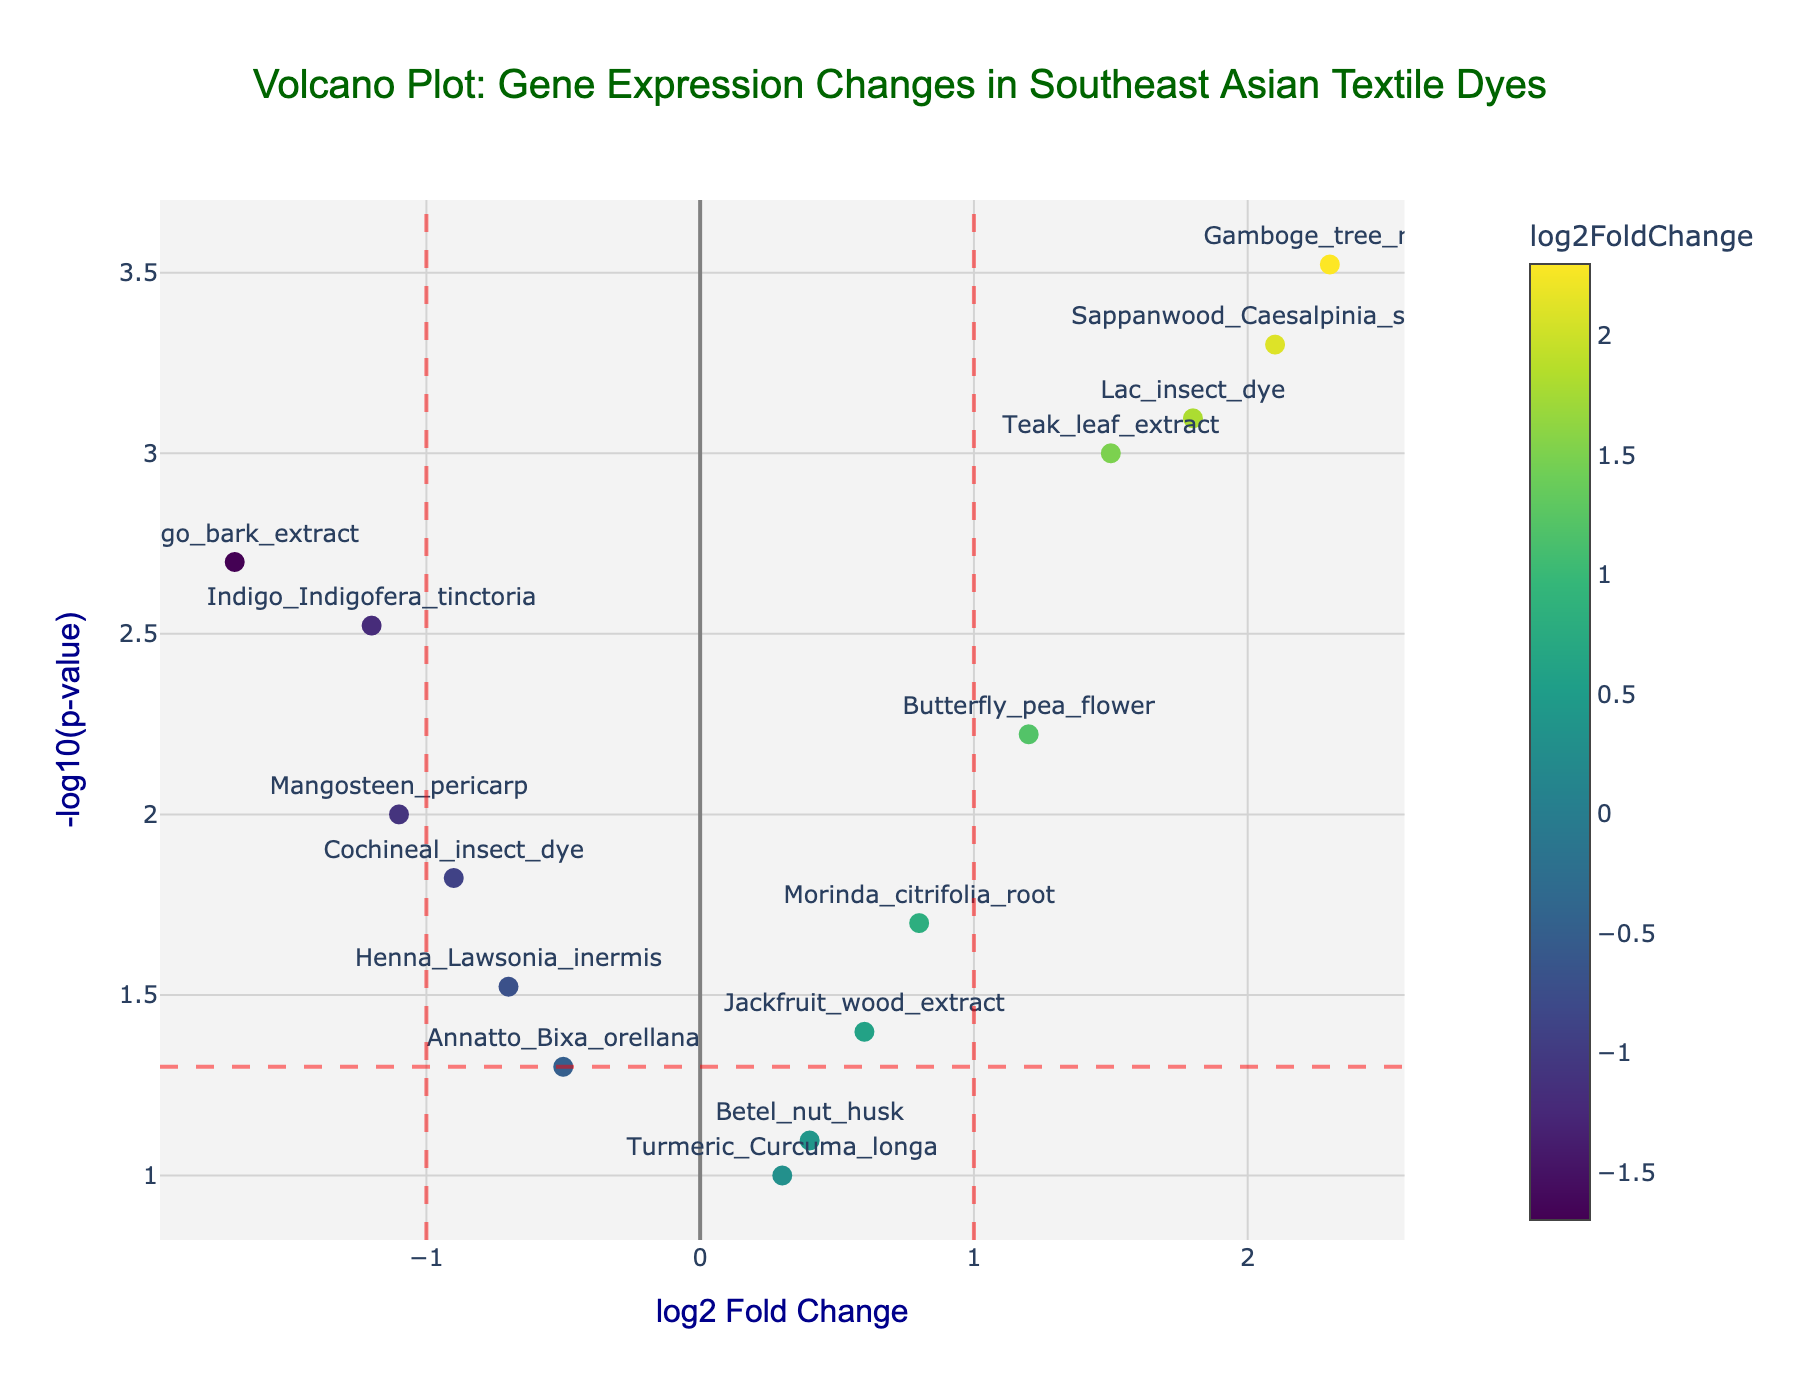What is the title of the figure? The title is displayed at the top of the figure in a larger, dark green font. It reads "Volcano Plot: Gene Expression Changes in Southeast Asian Textile Dyes".
Answer: Volcano Plot: Gene Expression Changes in Southeast Asian Textile Dyes What is the x-axis label of the plot? The x-axis label is located directly below the horizontal axis and reads "log2 Fold Change" in a dark blue font.
Answer: log2 Fold Change Which dye has the highest -log10(p-value)? By looking at the vertical axis and identifying the highest point, "Gamboge_tree_resin" has the largest -log10(p-value) value.
Answer: Gamboge_tree_resin How many data points have a log2FoldChange greater than 0 and a p-value less than 0.05? Points with a p-value less than 0.05 are those above the horizontal red dashed line at y ≈ 1.301 (-log10(0.05)), and points with log2FoldChange > 0 are to the right of the vertical axis (x > 0). Identifying those points: Morinda_citrifolia_root, Teak_leaf_extract, Sappanwood_Caesalpinia_sappan, Lac_insect_dye, Butterfly_pea_flower, and Gamboge_tree_resin.
Answer: 6 Which dye showed the largest negative log2FoldChange? We need to find the leftmost data point on the plot, indicating the largest negative log2FoldChange. This dye is "Mango_bark_extract" with a log2FoldChange of -1.7.
Answer: Mango_bark_extract Are any dyes both highly significant (p-value < 0.001) and have a positive log2FoldChange? To find this, locate points above the threshold of -log10(0.001) ≈ 3 and to the right of the vertical axis (log2FoldChange > 0). The points that meet this criterion are "Teak_leaf_extract", "Sappanwood_Caesalpinia_sappan", "Lac_insect_dye", and "Gamboge_tree_resin".
Answer: Yes Which dyes fall into the non-significant category (p-value >= 0.05)? Dyes with p-values >= 0.05 will be below the y = -log10(0.05) threshold, identifying "Turmeric_Curcuma_longa", "Annatto_Bixa_orellana", and "Betel_nut_husk".
Answer: Turmeric_Curcuma_longa, Annatto_Bixa_orellana, Betel_nut_husk Which dye is closest to the significance threshold line with a log2FoldChange < 0? Identify the dye just below or closest to the horizontal red dashed line (y = 1.301) with a log2FoldChange < 0. "Mangosteen_pericarp" is the closest to this line.
Answer: Mangosteen_pericarp 